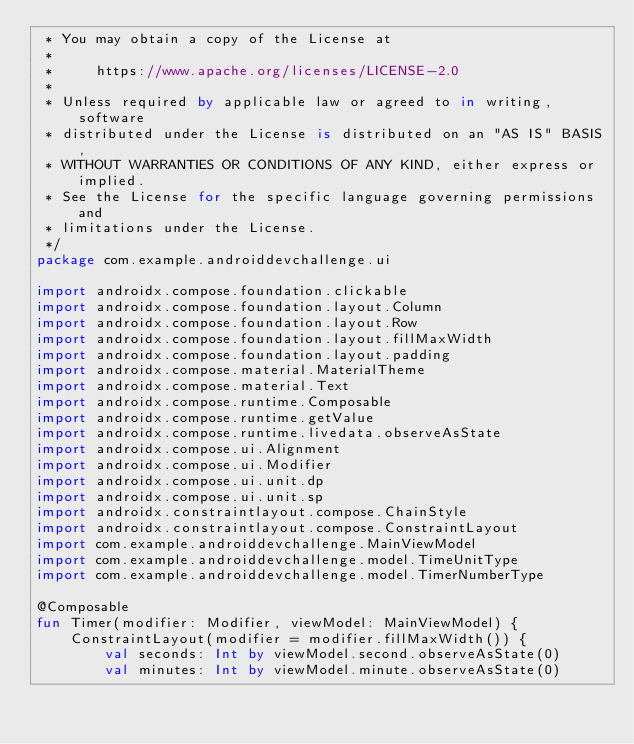Convert code to text. <code><loc_0><loc_0><loc_500><loc_500><_Kotlin_> * You may obtain a copy of the License at
 *
 *     https://www.apache.org/licenses/LICENSE-2.0
 *
 * Unless required by applicable law or agreed to in writing, software
 * distributed under the License is distributed on an "AS IS" BASIS,
 * WITHOUT WARRANTIES OR CONDITIONS OF ANY KIND, either express or implied.
 * See the License for the specific language governing permissions and
 * limitations under the License.
 */
package com.example.androiddevchallenge.ui

import androidx.compose.foundation.clickable
import androidx.compose.foundation.layout.Column
import androidx.compose.foundation.layout.Row
import androidx.compose.foundation.layout.fillMaxWidth
import androidx.compose.foundation.layout.padding
import androidx.compose.material.MaterialTheme
import androidx.compose.material.Text
import androidx.compose.runtime.Composable
import androidx.compose.runtime.getValue
import androidx.compose.runtime.livedata.observeAsState
import androidx.compose.ui.Alignment
import androidx.compose.ui.Modifier
import androidx.compose.ui.unit.dp
import androidx.compose.ui.unit.sp
import androidx.constraintlayout.compose.ChainStyle
import androidx.constraintlayout.compose.ConstraintLayout
import com.example.androiddevchallenge.MainViewModel
import com.example.androiddevchallenge.model.TimeUnitType
import com.example.androiddevchallenge.model.TimerNumberType

@Composable
fun Timer(modifier: Modifier, viewModel: MainViewModel) {
    ConstraintLayout(modifier = modifier.fillMaxWidth()) {
        val seconds: Int by viewModel.second.observeAsState(0)
        val minutes: Int by viewModel.minute.observeAsState(0)</code> 